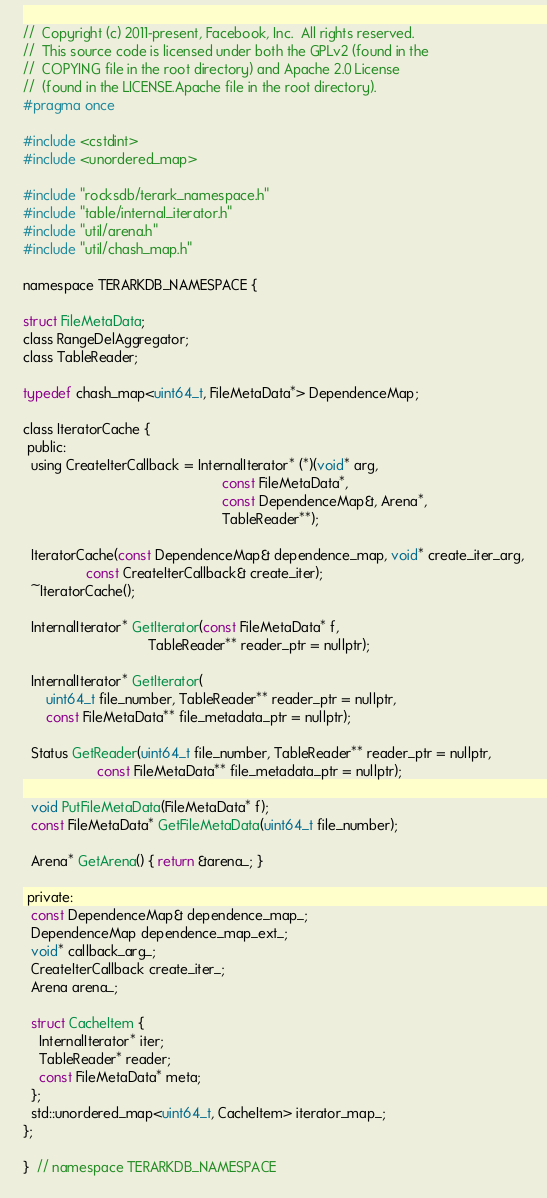Convert code to text. <code><loc_0><loc_0><loc_500><loc_500><_C_>//  Copyright (c) 2011-present, Facebook, Inc.  All rights reserved.
//  This source code is licensed under both the GPLv2 (found in the
//  COPYING file in the root directory) and Apache 2.0 License
//  (found in the LICENSE.Apache file in the root directory).
#pragma once

#include <cstdint>
#include <unordered_map>

#include "rocksdb/terark_namespace.h"
#include "table/internal_iterator.h"
#include "util/arena.h"
#include "util/chash_map.h"

namespace TERARKDB_NAMESPACE {

struct FileMetaData;
class RangeDelAggregator;
class TableReader;

typedef chash_map<uint64_t, FileMetaData*> DependenceMap;

class IteratorCache {
 public:
  using CreateIterCallback = InternalIterator* (*)(void* arg,
                                                   const FileMetaData*,
                                                   const DependenceMap&, Arena*,
                                                   TableReader**);

  IteratorCache(const DependenceMap& dependence_map, void* create_iter_arg,
                const CreateIterCallback& create_iter);
  ~IteratorCache();

  InternalIterator* GetIterator(const FileMetaData* f,
                                TableReader** reader_ptr = nullptr);

  InternalIterator* GetIterator(
      uint64_t file_number, TableReader** reader_ptr = nullptr,
      const FileMetaData** file_metadata_ptr = nullptr);

  Status GetReader(uint64_t file_number, TableReader** reader_ptr = nullptr,
                   const FileMetaData** file_metadata_ptr = nullptr);

  void PutFileMetaData(FileMetaData* f);
  const FileMetaData* GetFileMetaData(uint64_t file_number);

  Arena* GetArena() { return &arena_; }

 private:
  const DependenceMap& dependence_map_;
  DependenceMap dependence_map_ext_;
  void* callback_arg_;
  CreateIterCallback create_iter_;
  Arena arena_;

  struct CacheItem {
    InternalIterator* iter;
    TableReader* reader;
    const FileMetaData* meta;
  };
  std::unordered_map<uint64_t, CacheItem> iterator_map_;
};

}  // namespace TERARKDB_NAMESPACE</code> 